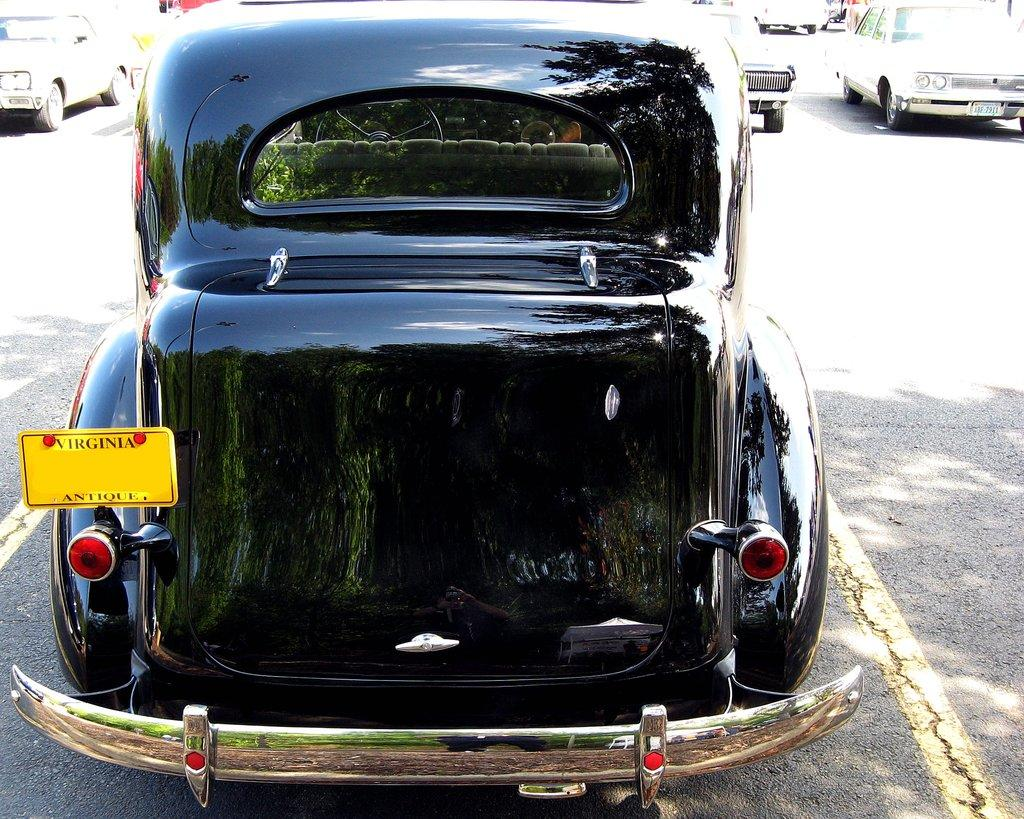What color is the car in the image? The car in the image is black. Where is the car located in the image? The car is on the road. Can you describe the surroundings of the car? There are vehicles visible in the background of the image. Are there any birds flying around the car in the image? There is no mention of birds in the image, so we cannot determine if they are present or not. 